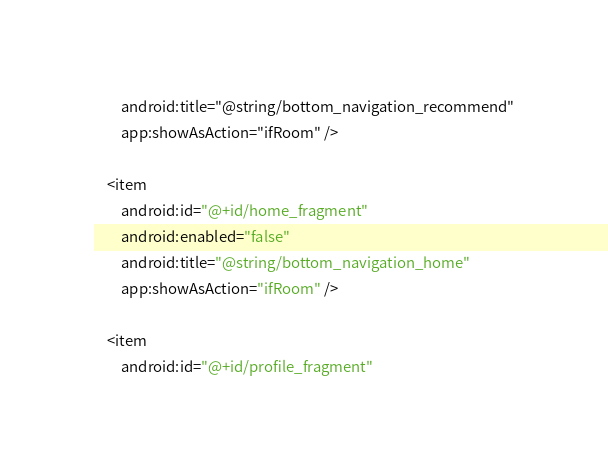<code> <loc_0><loc_0><loc_500><loc_500><_XML_>        android:title="@string/bottom_navigation_recommend"
        app:showAsAction="ifRoom" />

    <item
        android:id="@+id/home_fragment"
        android:enabled="false"
        android:title="@string/bottom_navigation_home"
        app:showAsAction="ifRoom" />

    <item
        android:id="@+id/profile_fragment"</code> 